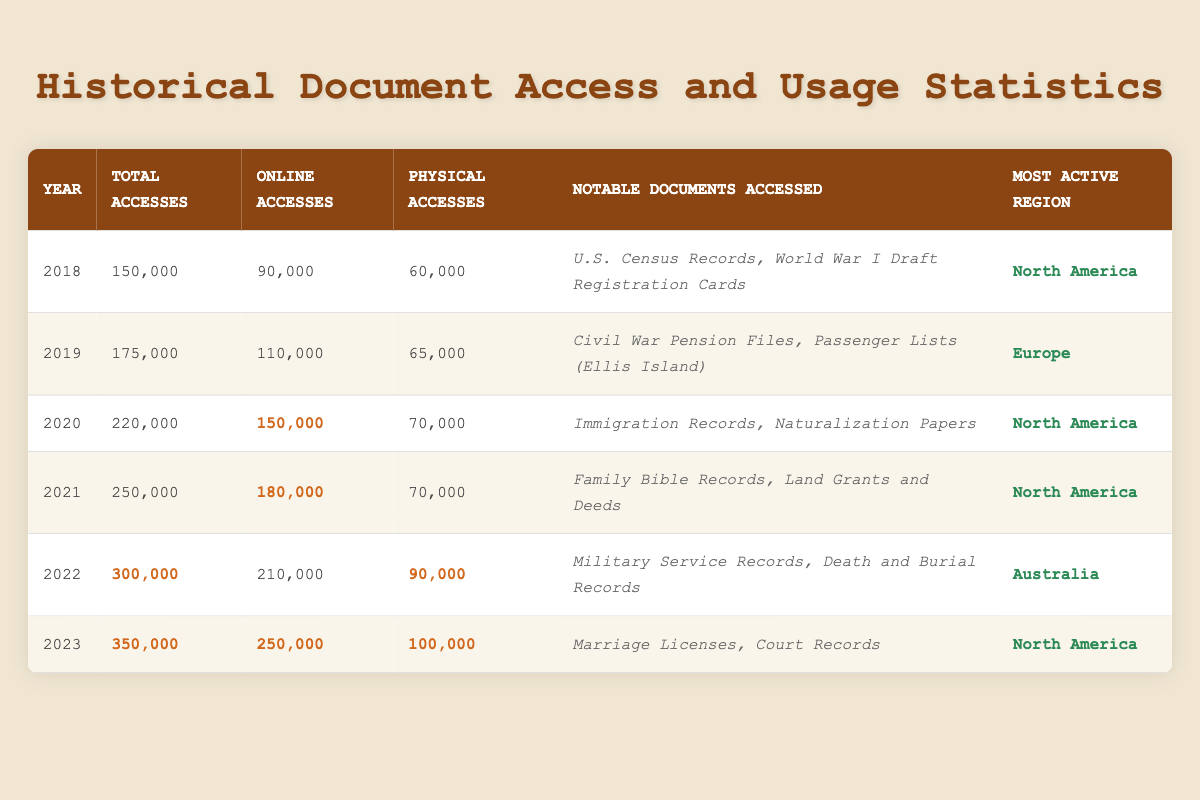What was the total number of accesses in 2021? In the table, the total accesses for the year 2021 is listed directly in the respective row. It shows 250,000 accesses for that year.
Answer: 250,000 Which year had the highest online accesses? To find the year with the highest online accesses, I compare the online access numbers from each year. The most online accesses (250,000) occurred in 2023.
Answer: 2023 How many more total accesses were there in 2022 compared to 2018? I look at the total accesses for 2022 (300,000) and 2018 (150,000) and subtract: 300,000 - 150,000 = 150,000.
Answer: 150,000 What percentage of the total accesses in 2020 were online accesses? The total accesses in 2020 are 220,000, and the online accesses are 150,000. To find the percentage, I calculate (150,000 / 220,000) * 100 = approximately 68.18%.
Answer: 68.18% Was there a year where the physical accesses were higher than the online accesses? I can see from the table that in 2018, physical accesses (60,000) were less than online accesses (90,000). The same goes for every other year as online accesses were higher. Therefore, there wasn't any year where physical accesses were higher.
Answer: No How many total accesses were there from 2020 to 2022 combined? I add the total accesses from 2020 (220,000), 2021 (250,000), and 2022 (300,000): 220,000 + 250,000 + 300,000 = 770,000.
Answer: 770,000 What was the most active region in 2022? The table lists the most active region for 2022 directly, which is Australia.
Answer: Australia In what year was there a significant increase in both total accesses and online accesses compared to the previous year? I compare the total and online accesses year by year. From 2021 to 2022, total accesses increased from 250,000 to 300,000 (an increase of 50,000), and online accesses increased from 180,000 to 210,000 (an increase of 30,000).
Answer: 2022 What was the average number of physical accesses from 2018 to 2023? I add together all the physical accesses from 2018 (60,000), 2019 (65,000), 2020 (70,000), 2021 (70,000), 2022 (90,000), and 2023 (100,000). This gives a total of 455,000. Then, I divide by the number of years (6): 455,000 / 6 = approximately 75,833.33.
Answer: 75,833.33 Which notable document was accessed the most in the years listed? To determine the most frequently accessed notable document from the years, I would need to gather all notable documents listed, but they are distinct documents per year listed. Therefore, no single document stands out as accessed multiple years.
Answer: No single document How many accesses were there in 2019 compared to 2020? From the table, 2019 had 175,000 accesses, and 2020 had 220,000 accesses. I can directly compare these two numbers to see that 2020 had 45,000 more accesses than 2019.
Answer: 45,000 more in 2020 